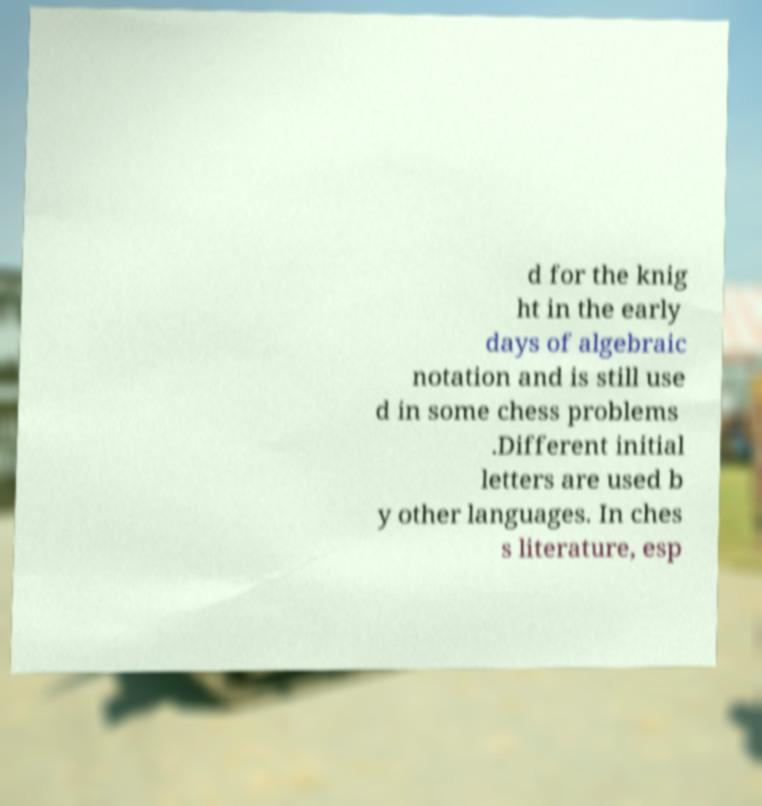Could you extract and type out the text from this image? d for the knig ht in the early days of algebraic notation and is still use d in some chess problems .Different initial letters are used b y other languages. In ches s literature, esp 